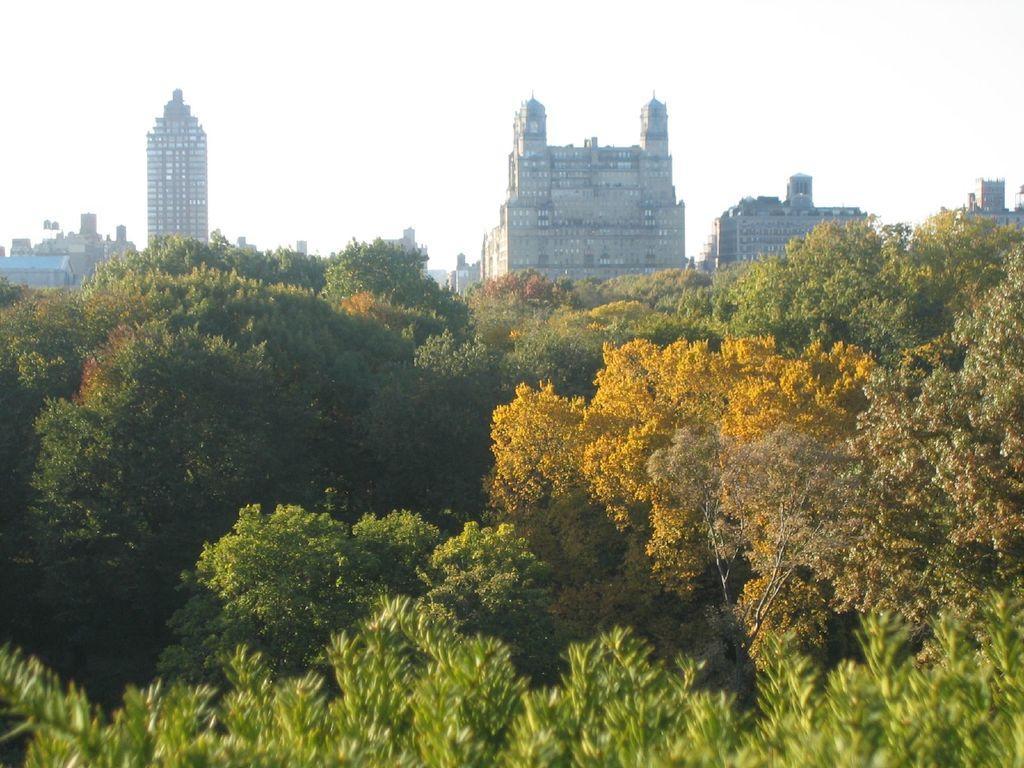How would you summarize this image in a sentence or two? In this image there is forest at the bottom. In the background there are tall buildings one beside the other. At the top there is the sky. 